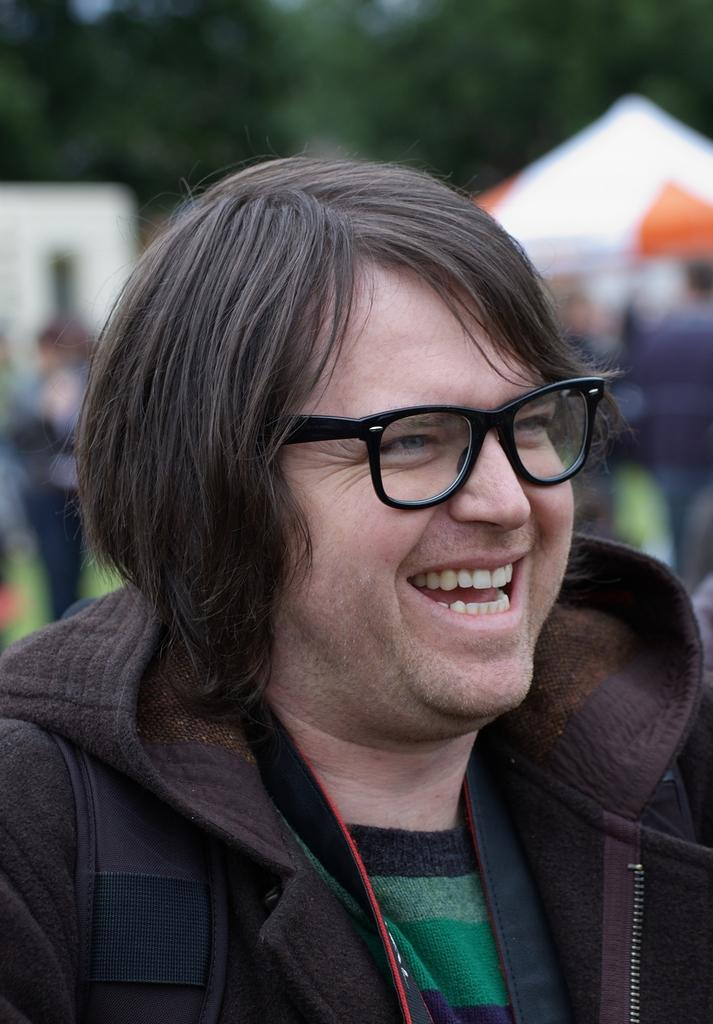Who or what is the main subject in the image? There is a person in the image. What accessory is the person wearing? The person is wearing glasses. Can you describe the background of the image? The background of the image is blurred. What type of grape can be seen growing in the background of the image? There is no grape or vineyard present in the image; the background is blurred. 